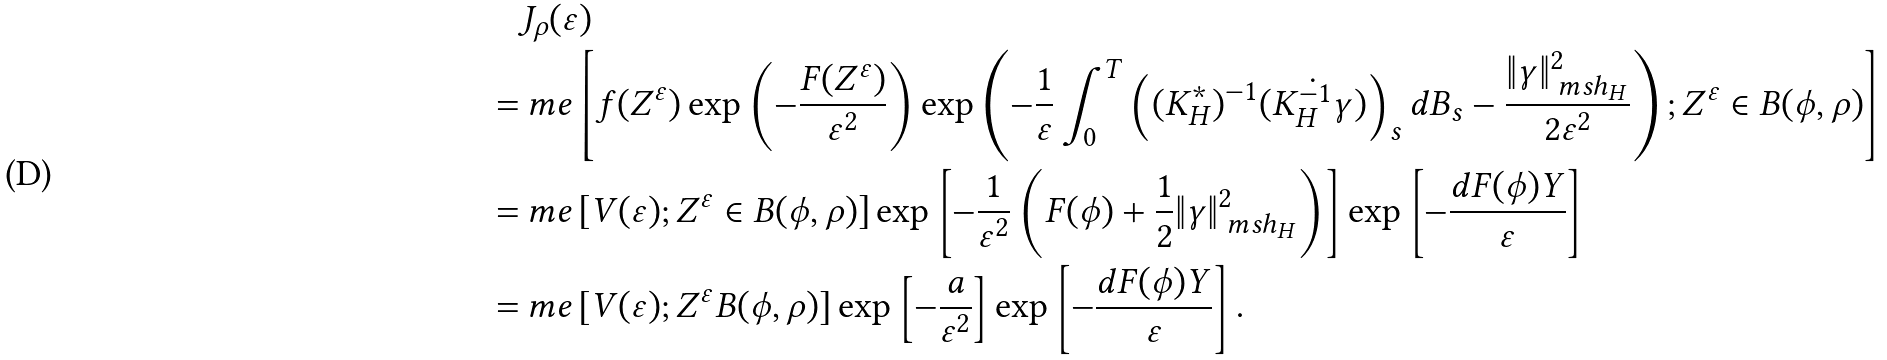Convert formula to latex. <formula><loc_0><loc_0><loc_500><loc_500>& J _ { \rho } ( \varepsilon ) \\ = & \ m e \left [ f ( Z ^ { \varepsilon } ) \exp \left ( - \frac { F ( Z ^ { \varepsilon } ) } { \varepsilon ^ { 2 } } \right ) \exp \left ( - \frac { 1 } { \varepsilon } \int _ { 0 } ^ { T } \left ( ( K ^ { * } _ { H } ) ^ { - 1 } ( \dot { K _ { H } ^ { - 1 } { \gamma } } ) \right ) _ { s } d B _ { s } - \frac { \| \gamma \| ^ { 2 } _ { \ m s h _ { H } } } { 2 \varepsilon ^ { 2 } } \right ) ; Z ^ { \varepsilon } \in B ( \phi , \rho ) \right ] \\ = & \ m e \left [ V ( \varepsilon ) ; Z ^ { \varepsilon } \in B ( \phi , \rho ) \right ] \exp \left [ - \frac { 1 } { \varepsilon ^ { 2 } } \left ( F ( \phi ) + \frac { 1 } { 2 } \| \gamma \| ^ { 2 } _ { \ m s h _ { H } } \right ) \right ] \exp \left [ - \frac { d F ( \phi ) Y } { \varepsilon } \right ] \\ = & \ m e \left [ V ( \varepsilon ) ; Z ^ { \varepsilon } B ( \phi , \rho ) \right ] \exp \left [ - \frac { a } { \varepsilon ^ { 2 } } \right ] \exp \left [ - \frac { d F ( \phi ) Y } { \varepsilon } \right ] .</formula> 